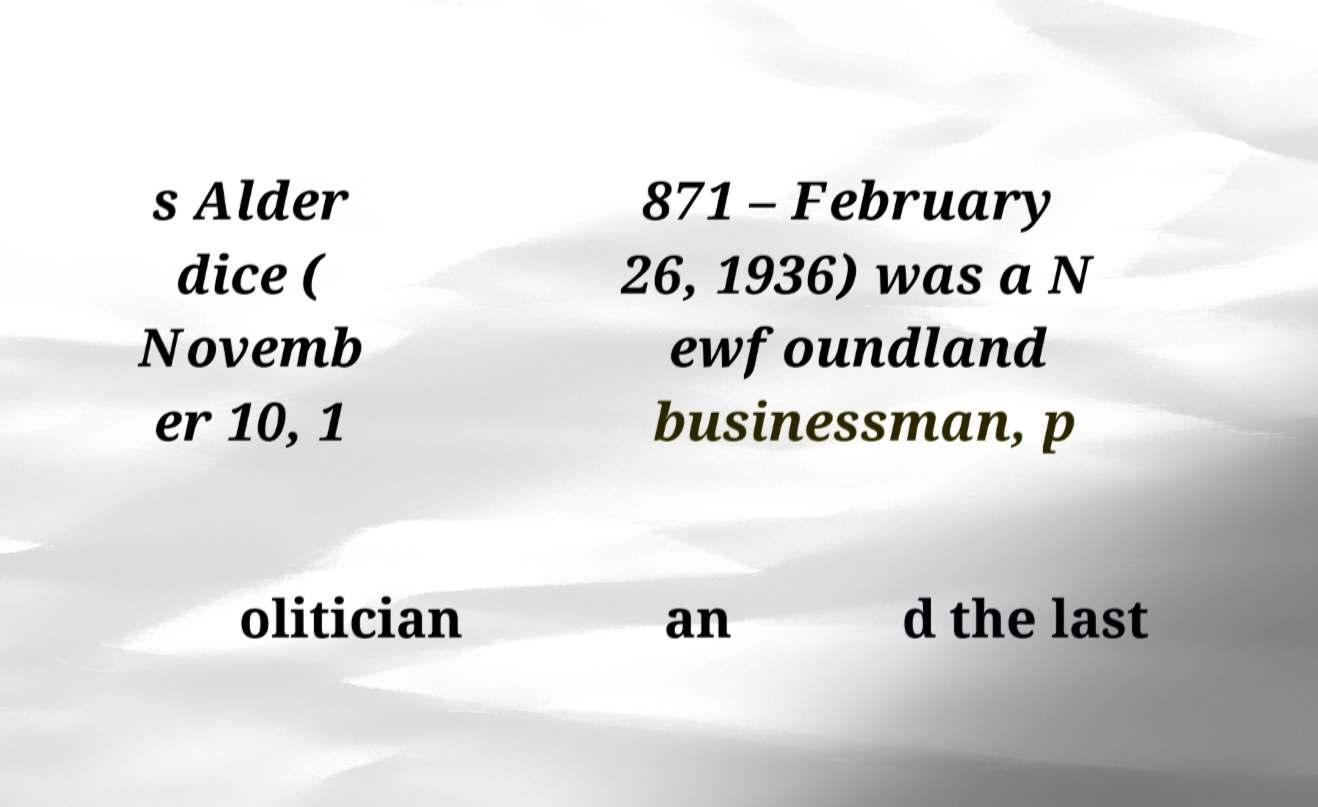Can you read and provide the text displayed in the image?This photo seems to have some interesting text. Can you extract and type it out for me? s Alder dice ( Novemb er 10, 1 871 – February 26, 1936) was a N ewfoundland businessman, p olitician an d the last 